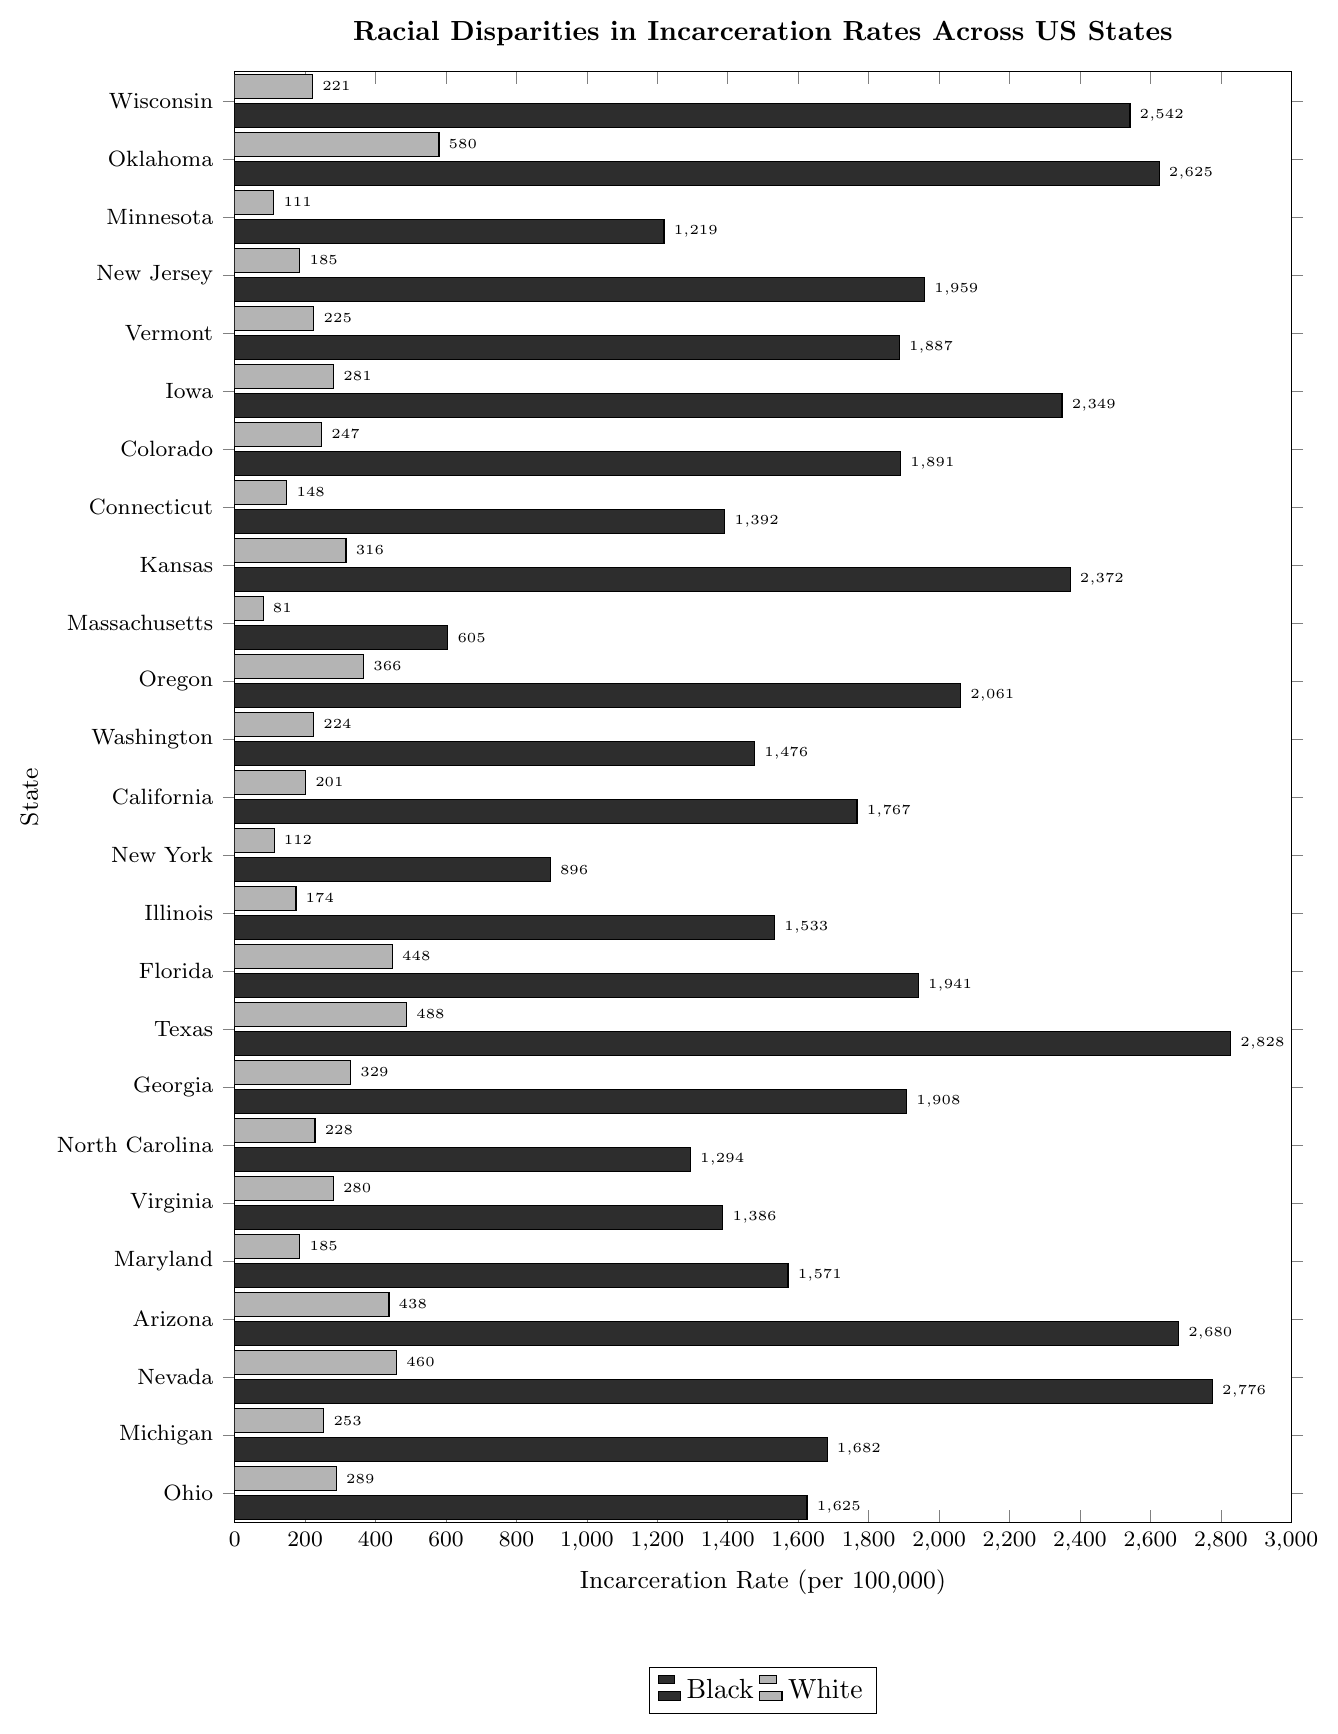Which state has the highest incarceration rate for Black individuals? By looking at the bar representing Black individuals' incarceration rates, we find the longest bar that corresponds to Texas.
Answer: Texas In which state is the disparity in incarceration rates between Black and White individuals the greatest? Calculate the difference between the bars (Black - White) for each state. Texas has the highest disparity (2828 - 488 = 2340).
Answer: Texas Which state has the lowest incarceration rate for Black individuals? Find the shortest bar representing Black individuals' incarceration rates, which corresponds to Massachusetts.
Answer: Massachusetts Compare the incarceration rates for Black and White individuals in Wisconsin. Which group has a higher rate, and by how much? The bar for Black individuals in Wisconsin is at 2542, and for White individuals at 221. The difference is 2542 - 221 = 2321. Black individuals have a higher rate by 2321.
Answer: Black, 2321 What is the average incarceration rate for Black individuals across all the states listed? Sum all the incarceration rates for Black individuals and divide by the number of states: (2542 + 2625 + 1219 + 1959 + 1887 + 2349 + 1891 + 1392 + 2372 + 605 + 2061 + 1476 + 1767 + 896 + 1533 + 1941 + 2828 + 1908 + 1294 + 1386 + 1571 + 2680 + 2776 + 1682 + 1625) / 25. The total sum is 43694, so the average is 43694 / 25 = 1747.76.
Answer: 1747.76 Which state has the smallest disparity in incarceration rates between Black and White individuals? Calculate the difference between the bars (Black - White) for each state. Massachusetts has the smallest disparity (605 - 81 = 524).
Answer: Massachusetts Identify the states where the incarceration rate for White individuals exceeds 400. By examining the bars for White individuals, the states meeting this criterion are Oklahoma (580), Florida (448), Texas (488), Arizona (438), and Nevada (460).
Answer: Oklahoma, Florida, Texas, Arizona, Nevada In which states is the Black incarceration rate more than ten times the White rate? For each state, check if the bar for Black individuals is more than ten times the bar for White individuals. This criterion is met by Wisconsin (2542 > 10 * 221), Minnesota (1219 > 10 * 111), and Connecticut (1392 > 10 * 148).
Answer: Wisconsin, Minnesota, Connecticut What is the median incarceration rate for Black individuals across all states listed? To find the median, order the incarceration rates and find the middle value: [605, 896, 1219, 1294, 1386, 1392, 1476, 1533, 1571, 1625, 1682, 1767, 1887, 1891, 1908, 1941, 1959, 2061, 2349, 2372, 2542, 2625, 2680, 2776, 2828]. The middle value (13th in a sequence of 25) is 1767.
Answer: 1767 Compare the incarceration rates in New Jersey. Are Black individuals incarcerated at more than ten times the rate of White individuals? The incarceration rate for Black individuals in New Jersey is 1959, and for White individuals, it is 185. Since 1959 > 10 * 185 (which is 1850), the statement holds true.
Answer: Yes 